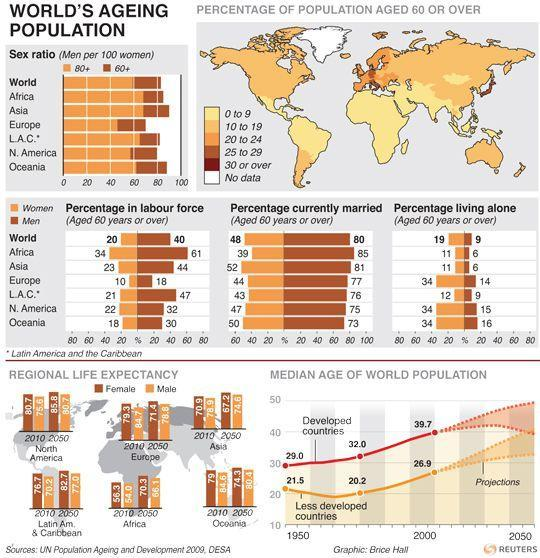What percentage of women and men in Africa currently married?
Answer the question with a short phrase. 124 What percentage of women and men in the world currently married? 128 What percentage of women and men in the world are living alone? 28 